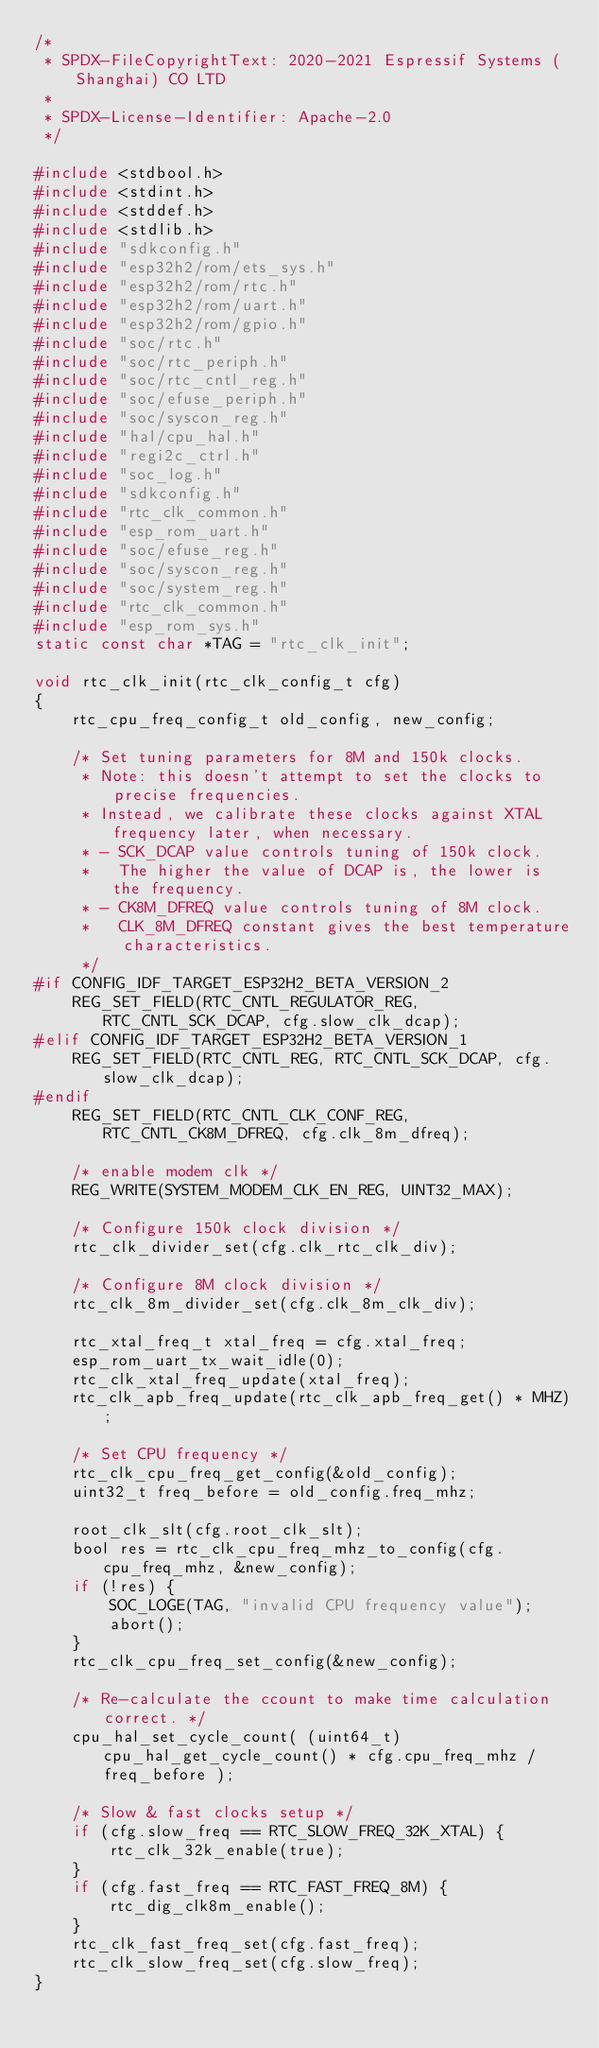<code> <loc_0><loc_0><loc_500><loc_500><_C_>/*
 * SPDX-FileCopyrightText: 2020-2021 Espressif Systems (Shanghai) CO LTD
 *
 * SPDX-License-Identifier: Apache-2.0
 */

#include <stdbool.h>
#include <stdint.h>
#include <stddef.h>
#include <stdlib.h>
#include "sdkconfig.h"
#include "esp32h2/rom/ets_sys.h"
#include "esp32h2/rom/rtc.h"
#include "esp32h2/rom/uart.h"
#include "esp32h2/rom/gpio.h"
#include "soc/rtc.h"
#include "soc/rtc_periph.h"
#include "soc/rtc_cntl_reg.h"
#include "soc/efuse_periph.h"
#include "soc/syscon_reg.h"
#include "hal/cpu_hal.h"
#include "regi2c_ctrl.h"
#include "soc_log.h"
#include "sdkconfig.h"
#include "rtc_clk_common.h"
#include "esp_rom_uart.h"
#include "soc/efuse_reg.h"
#include "soc/syscon_reg.h"
#include "soc/system_reg.h"
#include "rtc_clk_common.h"
#include "esp_rom_sys.h"
static const char *TAG = "rtc_clk_init";

void rtc_clk_init(rtc_clk_config_t cfg)
{
    rtc_cpu_freq_config_t old_config, new_config;

    /* Set tuning parameters for 8M and 150k clocks.
     * Note: this doesn't attempt to set the clocks to precise frequencies.
     * Instead, we calibrate these clocks against XTAL frequency later, when necessary.
     * - SCK_DCAP value controls tuning of 150k clock.
     *   The higher the value of DCAP is, the lower is the frequency.
     * - CK8M_DFREQ value controls tuning of 8M clock.
     *   CLK_8M_DFREQ constant gives the best temperature characteristics.
     */
#if CONFIG_IDF_TARGET_ESP32H2_BETA_VERSION_2
    REG_SET_FIELD(RTC_CNTL_REGULATOR_REG, RTC_CNTL_SCK_DCAP, cfg.slow_clk_dcap);
#elif CONFIG_IDF_TARGET_ESP32H2_BETA_VERSION_1
    REG_SET_FIELD(RTC_CNTL_REG, RTC_CNTL_SCK_DCAP, cfg.slow_clk_dcap);
#endif
    REG_SET_FIELD(RTC_CNTL_CLK_CONF_REG, RTC_CNTL_CK8M_DFREQ, cfg.clk_8m_dfreq);

    /* enable modem clk */
    REG_WRITE(SYSTEM_MODEM_CLK_EN_REG, UINT32_MAX);

    /* Configure 150k clock division */
    rtc_clk_divider_set(cfg.clk_rtc_clk_div);

    /* Configure 8M clock division */
    rtc_clk_8m_divider_set(cfg.clk_8m_clk_div);

    rtc_xtal_freq_t xtal_freq = cfg.xtal_freq;
    esp_rom_uart_tx_wait_idle(0);
    rtc_clk_xtal_freq_update(xtal_freq);
    rtc_clk_apb_freq_update(rtc_clk_apb_freq_get() * MHZ);

    /* Set CPU frequency */
    rtc_clk_cpu_freq_get_config(&old_config);
    uint32_t freq_before = old_config.freq_mhz;

    root_clk_slt(cfg.root_clk_slt);
    bool res = rtc_clk_cpu_freq_mhz_to_config(cfg.cpu_freq_mhz, &new_config);
    if (!res) {
        SOC_LOGE(TAG, "invalid CPU frequency value");
        abort();
    }
    rtc_clk_cpu_freq_set_config(&new_config);

    /* Re-calculate the ccount to make time calculation correct. */
    cpu_hal_set_cycle_count( (uint64_t)cpu_hal_get_cycle_count() * cfg.cpu_freq_mhz / freq_before );

    /* Slow & fast clocks setup */
    if (cfg.slow_freq == RTC_SLOW_FREQ_32K_XTAL) {
        rtc_clk_32k_enable(true);
    }
    if (cfg.fast_freq == RTC_FAST_FREQ_8M) {
        rtc_dig_clk8m_enable();
    }
    rtc_clk_fast_freq_set(cfg.fast_freq);
    rtc_clk_slow_freq_set(cfg.slow_freq);
}
</code> 